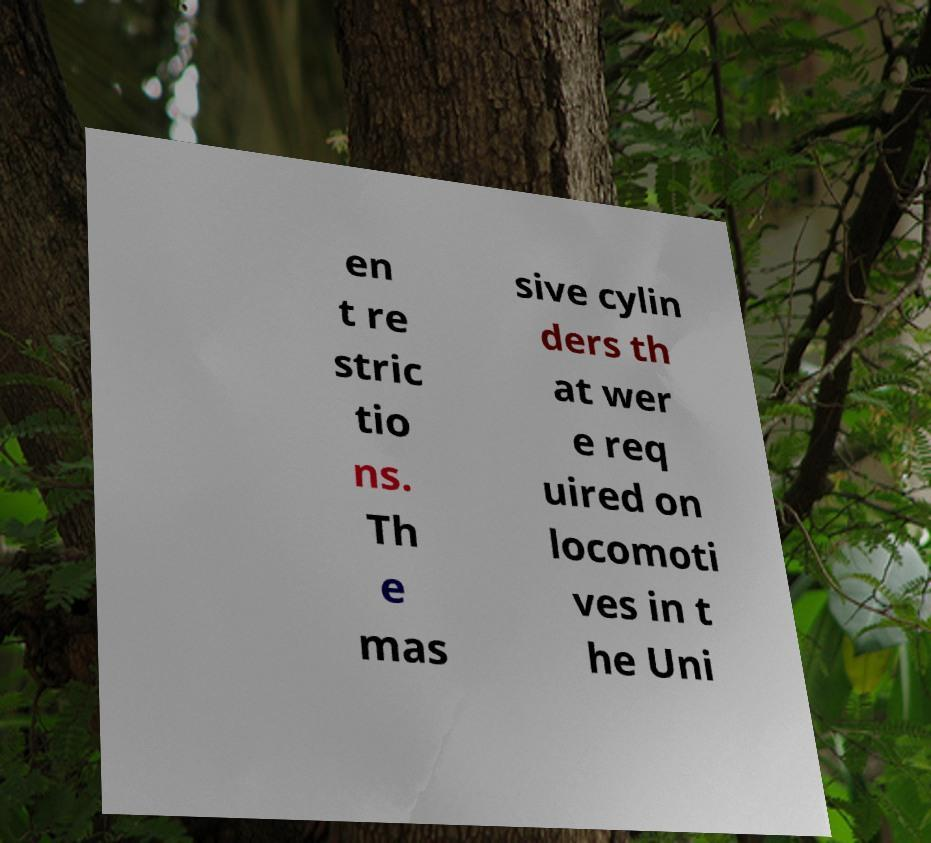I need the written content from this picture converted into text. Can you do that? en t re stric tio ns. Th e mas sive cylin ders th at wer e req uired on locomoti ves in t he Uni 